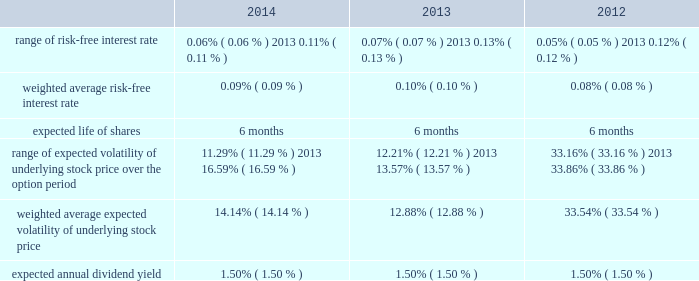American tower corporation and subsidiaries notes to consolidated financial statements six-month offering period .
The weighted average fair value per share of espp share purchase options during the year ended december 31 , 2014 , 2013 and 2012 was $ 14.83 , $ 13.42 and $ 13.64 , respectively .
At december 31 , 2014 , 3.4 million shares remain reserved for future issuance under the plan .
Key assumptions used to apply the black-scholes pricing model for shares purchased through the espp for the years ended december 31 , are as follows: .
16 .
Equity mandatory convertible preferred stock offering 2014on may 12 , 2014 , the company completed a registered public offering of 6000000 shares of its 5.25% ( 5.25 % ) mandatory convertible preferred stock , series a , par value $ 0.01 per share ( the 201cmandatory convertible preferred stock 201d ) .
The net proceeds of the offering were $ 582.9 million after deducting commissions and estimated expenses .
The company used the net proceeds from this offering to fund acquisitions , including the acquisition from richland , initially funded by indebtedness incurred under the 2013 credit facility .
Unless converted earlier , each share of the mandatory convertible preferred stock will automatically convert on may 15 , 2017 , into between 0.9174 and 1.1468 shares of common stock , depending on the applicable market value of the common stock and subject to anti-dilution adjustments .
Subject to certain restrictions , at any time prior to may 15 , 2017 , holders of the mandatory convertible preferred stock may elect to convert all or a portion of their shares into common stock at the minimum conversion rate then in effect .
Dividends on shares of mandatory convertible preferred stock are payable on a cumulative basis when , as and if declared by the company 2019s board of directors ( or an authorized committee thereof ) at an annual rate of 5.25% ( 5.25 % ) on the liquidation preference of $ 100.00 per share , on february 15 , may 15 , august 15 and november 15 of each year , commencing on august 15 , 2014 to , and including , may 15 , 2017 .
The company may pay dividends in cash or , subject to certain limitations , in shares of common stock or any combination of cash and shares of common stock .
The terms of the mandatory convertible preferred stock provide that , unless full cumulative dividends have been paid or set aside for payment on all outstanding mandatory convertible preferred stock for all prior dividend periods , no dividends may be declared or paid on common stock .
Stock repurchase program 2014in march 2011 , the board of directors approved a stock repurchase program , pursuant to which the company is authorized to purchase up to $ 1.5 billion of common stock ( 201c2011 buyback 201d ) .
In september 2013 , the company temporarily suspended repurchases in connection with its acquisition of mipt .
Under the 2011 buyback , the company is authorized to purchase shares from time to time through open market purchases or privately negotiated transactions at prevailing prices in accordance with securities laws and other legal requirements , and subject to market conditions and other factors .
To facilitate repurchases , the company .
Assuming a weighted average fair value per share equal to the average december 31 , 2014 cost , what would be the total expense for issuance of the remaining plan shares at 12/31/14? 
Computations: (14.83 * (1000000 * 3.4))
Answer: 50422000.0. 